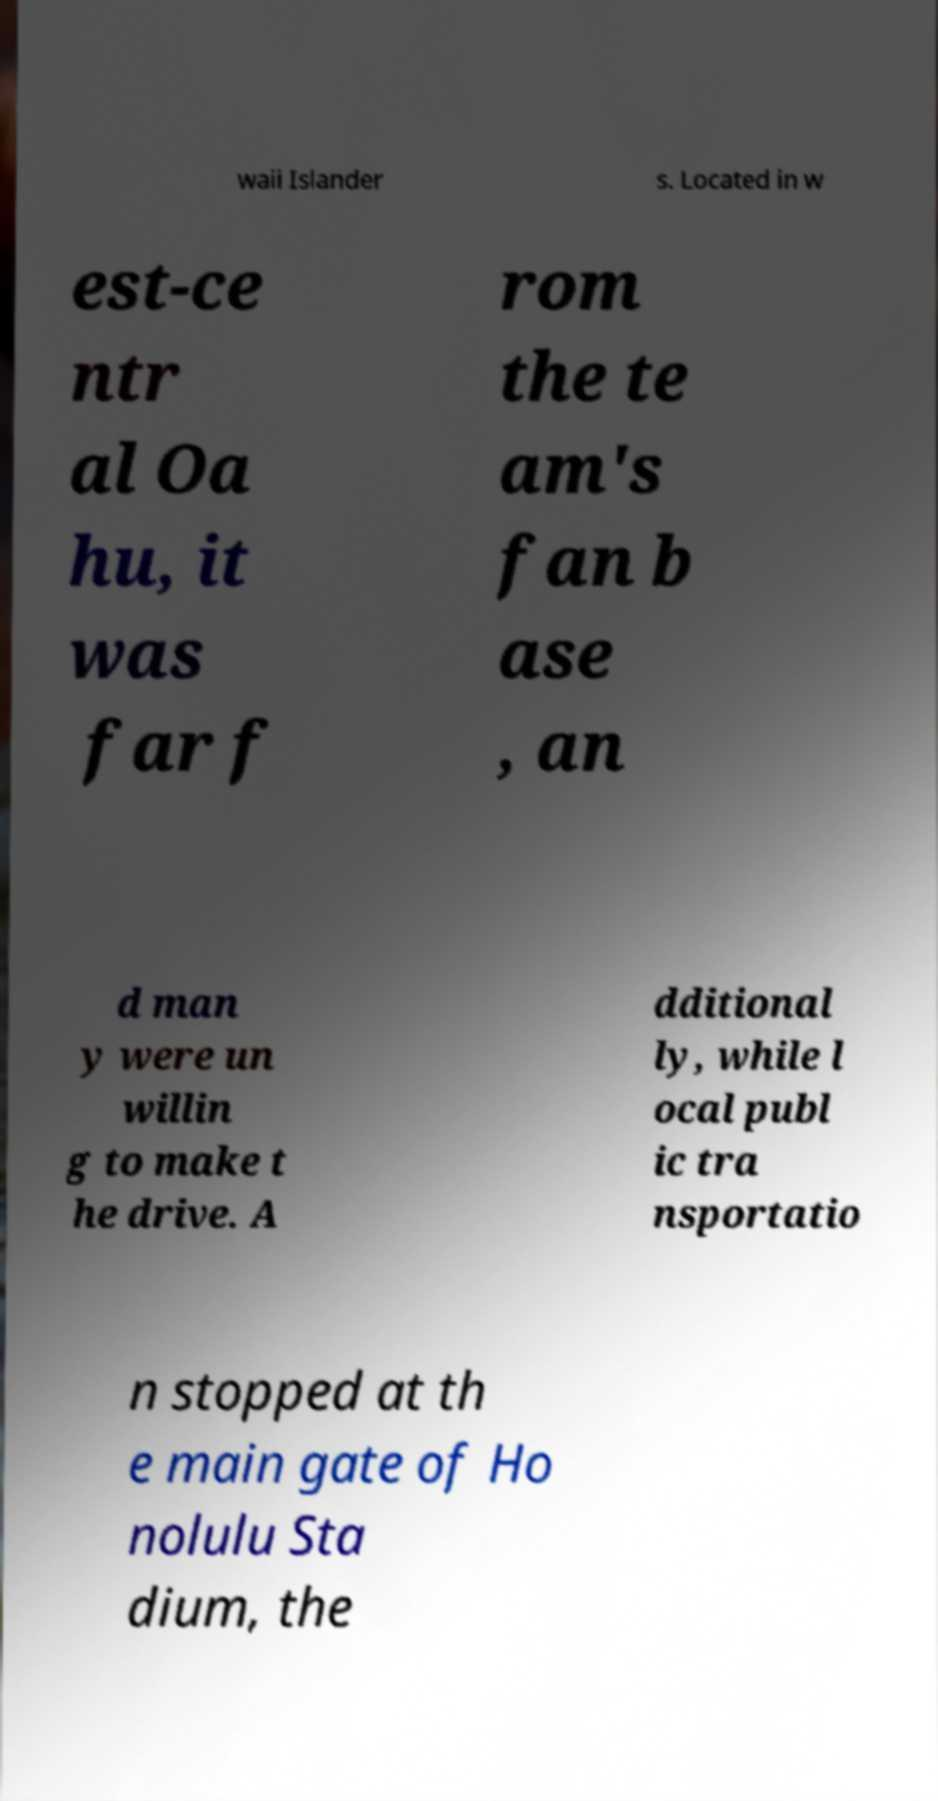What messages or text are displayed in this image? I need them in a readable, typed format. waii Islander s. Located in w est-ce ntr al Oa hu, it was far f rom the te am's fan b ase , an d man y were un willin g to make t he drive. A dditional ly, while l ocal publ ic tra nsportatio n stopped at th e main gate of Ho nolulu Sta dium, the 